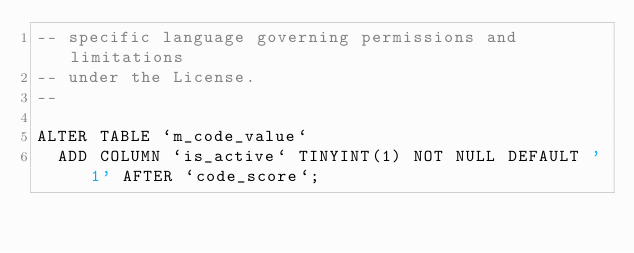Convert code to text. <code><loc_0><loc_0><loc_500><loc_500><_SQL_>-- specific language governing permissions and limitations
-- under the License.
--

ALTER TABLE `m_code_value`
	ADD COLUMN `is_active` TINYINT(1) NOT NULL DEFAULT '1' AFTER `code_score`;</code> 